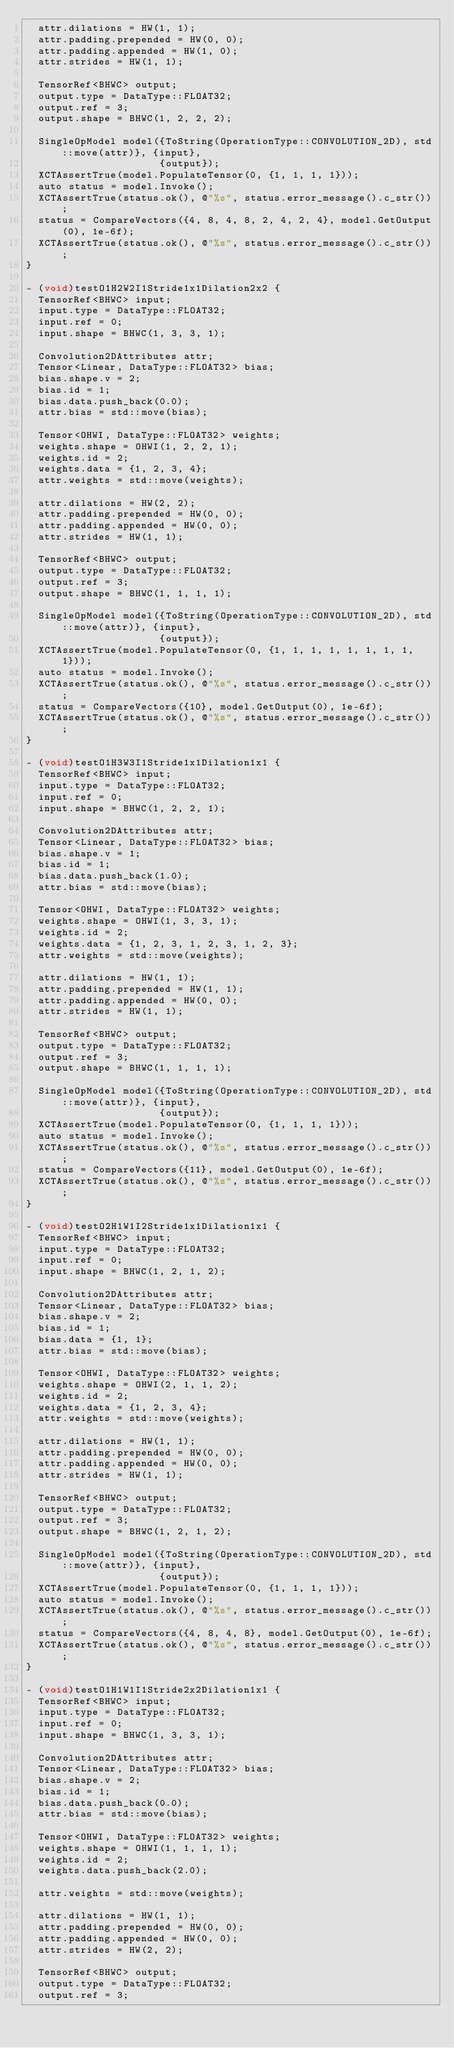<code> <loc_0><loc_0><loc_500><loc_500><_ObjectiveC_>  attr.dilations = HW(1, 1);
  attr.padding.prepended = HW(0, 0);
  attr.padding.appended = HW(1, 0);
  attr.strides = HW(1, 1);

  TensorRef<BHWC> output;
  output.type = DataType::FLOAT32;
  output.ref = 3;
  output.shape = BHWC(1, 2, 2, 2);

  SingleOpModel model({ToString(OperationType::CONVOLUTION_2D), std::move(attr)}, {input},
                      {output});
  XCTAssertTrue(model.PopulateTensor(0, {1, 1, 1, 1}));
  auto status = model.Invoke();
  XCTAssertTrue(status.ok(), @"%s", status.error_message().c_str());
  status = CompareVectors({4, 8, 4, 8, 2, 4, 2, 4}, model.GetOutput(0), 1e-6f);
  XCTAssertTrue(status.ok(), @"%s", status.error_message().c_str());
}

- (void)testO1H2W2I1Stride1x1Dilation2x2 {
  TensorRef<BHWC> input;
  input.type = DataType::FLOAT32;
  input.ref = 0;
  input.shape = BHWC(1, 3, 3, 1);

  Convolution2DAttributes attr;
  Tensor<Linear, DataType::FLOAT32> bias;
  bias.shape.v = 2;
  bias.id = 1;
  bias.data.push_back(0.0);
  attr.bias = std::move(bias);

  Tensor<OHWI, DataType::FLOAT32> weights;
  weights.shape = OHWI(1, 2, 2, 1);
  weights.id = 2;
  weights.data = {1, 2, 3, 4};
  attr.weights = std::move(weights);

  attr.dilations = HW(2, 2);
  attr.padding.prepended = HW(0, 0);
  attr.padding.appended = HW(0, 0);
  attr.strides = HW(1, 1);

  TensorRef<BHWC> output;
  output.type = DataType::FLOAT32;
  output.ref = 3;
  output.shape = BHWC(1, 1, 1, 1);

  SingleOpModel model({ToString(OperationType::CONVOLUTION_2D), std::move(attr)}, {input},
                      {output});
  XCTAssertTrue(model.PopulateTensor(0, {1, 1, 1, 1, 1, 1, 1, 1, 1}));
  auto status = model.Invoke();
  XCTAssertTrue(status.ok(), @"%s", status.error_message().c_str());
  status = CompareVectors({10}, model.GetOutput(0), 1e-6f);
  XCTAssertTrue(status.ok(), @"%s", status.error_message().c_str());
}

- (void)testO1H3W3I1Stride1x1Dilation1x1 {
  TensorRef<BHWC> input;
  input.type = DataType::FLOAT32;
  input.ref = 0;
  input.shape = BHWC(1, 2, 2, 1);

  Convolution2DAttributes attr;
  Tensor<Linear, DataType::FLOAT32> bias;
  bias.shape.v = 1;
  bias.id = 1;
  bias.data.push_back(1.0);
  attr.bias = std::move(bias);

  Tensor<OHWI, DataType::FLOAT32> weights;
  weights.shape = OHWI(1, 3, 3, 1);
  weights.id = 2;
  weights.data = {1, 2, 3, 1, 2, 3, 1, 2, 3};
  attr.weights = std::move(weights);

  attr.dilations = HW(1, 1);
  attr.padding.prepended = HW(1, 1);
  attr.padding.appended = HW(0, 0);
  attr.strides = HW(1, 1);

  TensorRef<BHWC> output;
  output.type = DataType::FLOAT32;
  output.ref = 3;
  output.shape = BHWC(1, 1, 1, 1);

  SingleOpModel model({ToString(OperationType::CONVOLUTION_2D), std::move(attr)}, {input},
                      {output});
  XCTAssertTrue(model.PopulateTensor(0, {1, 1, 1, 1}));
  auto status = model.Invoke();
  XCTAssertTrue(status.ok(), @"%s", status.error_message().c_str());
  status = CompareVectors({11}, model.GetOutput(0), 1e-6f);
  XCTAssertTrue(status.ok(), @"%s", status.error_message().c_str());
}

- (void)testO2H1W1I2Stride1x1Dilation1x1 {
  TensorRef<BHWC> input;
  input.type = DataType::FLOAT32;
  input.ref = 0;
  input.shape = BHWC(1, 2, 1, 2);

  Convolution2DAttributes attr;
  Tensor<Linear, DataType::FLOAT32> bias;
  bias.shape.v = 2;
  bias.id = 1;
  bias.data = {1, 1};
  attr.bias = std::move(bias);

  Tensor<OHWI, DataType::FLOAT32> weights;
  weights.shape = OHWI(2, 1, 1, 2);
  weights.id = 2;
  weights.data = {1, 2, 3, 4};
  attr.weights = std::move(weights);

  attr.dilations = HW(1, 1);
  attr.padding.prepended = HW(0, 0);
  attr.padding.appended = HW(0, 0);
  attr.strides = HW(1, 1);

  TensorRef<BHWC> output;
  output.type = DataType::FLOAT32;
  output.ref = 3;
  output.shape = BHWC(1, 2, 1, 2);

  SingleOpModel model({ToString(OperationType::CONVOLUTION_2D), std::move(attr)}, {input},
                      {output});
  XCTAssertTrue(model.PopulateTensor(0, {1, 1, 1, 1}));
  auto status = model.Invoke();
  XCTAssertTrue(status.ok(), @"%s", status.error_message().c_str());
  status = CompareVectors({4, 8, 4, 8}, model.GetOutput(0), 1e-6f);
  XCTAssertTrue(status.ok(), @"%s", status.error_message().c_str());
}

- (void)testO1H1W1I1Stride2x2Dilation1x1 {
  TensorRef<BHWC> input;
  input.type = DataType::FLOAT32;
  input.ref = 0;
  input.shape = BHWC(1, 3, 3, 1);

  Convolution2DAttributes attr;
  Tensor<Linear, DataType::FLOAT32> bias;
  bias.shape.v = 2;
  bias.id = 1;
  bias.data.push_back(0.0);
  attr.bias = std::move(bias);

  Tensor<OHWI, DataType::FLOAT32> weights;
  weights.shape = OHWI(1, 1, 1, 1);
  weights.id = 2;
  weights.data.push_back(2.0);

  attr.weights = std::move(weights);

  attr.dilations = HW(1, 1);
  attr.padding.prepended = HW(0, 0);
  attr.padding.appended = HW(0, 0);
  attr.strides = HW(2, 2);

  TensorRef<BHWC> output;
  output.type = DataType::FLOAT32;
  output.ref = 3;</code> 